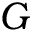Convert formula to latex. <formula><loc_0><loc_0><loc_500><loc_500>G</formula> 